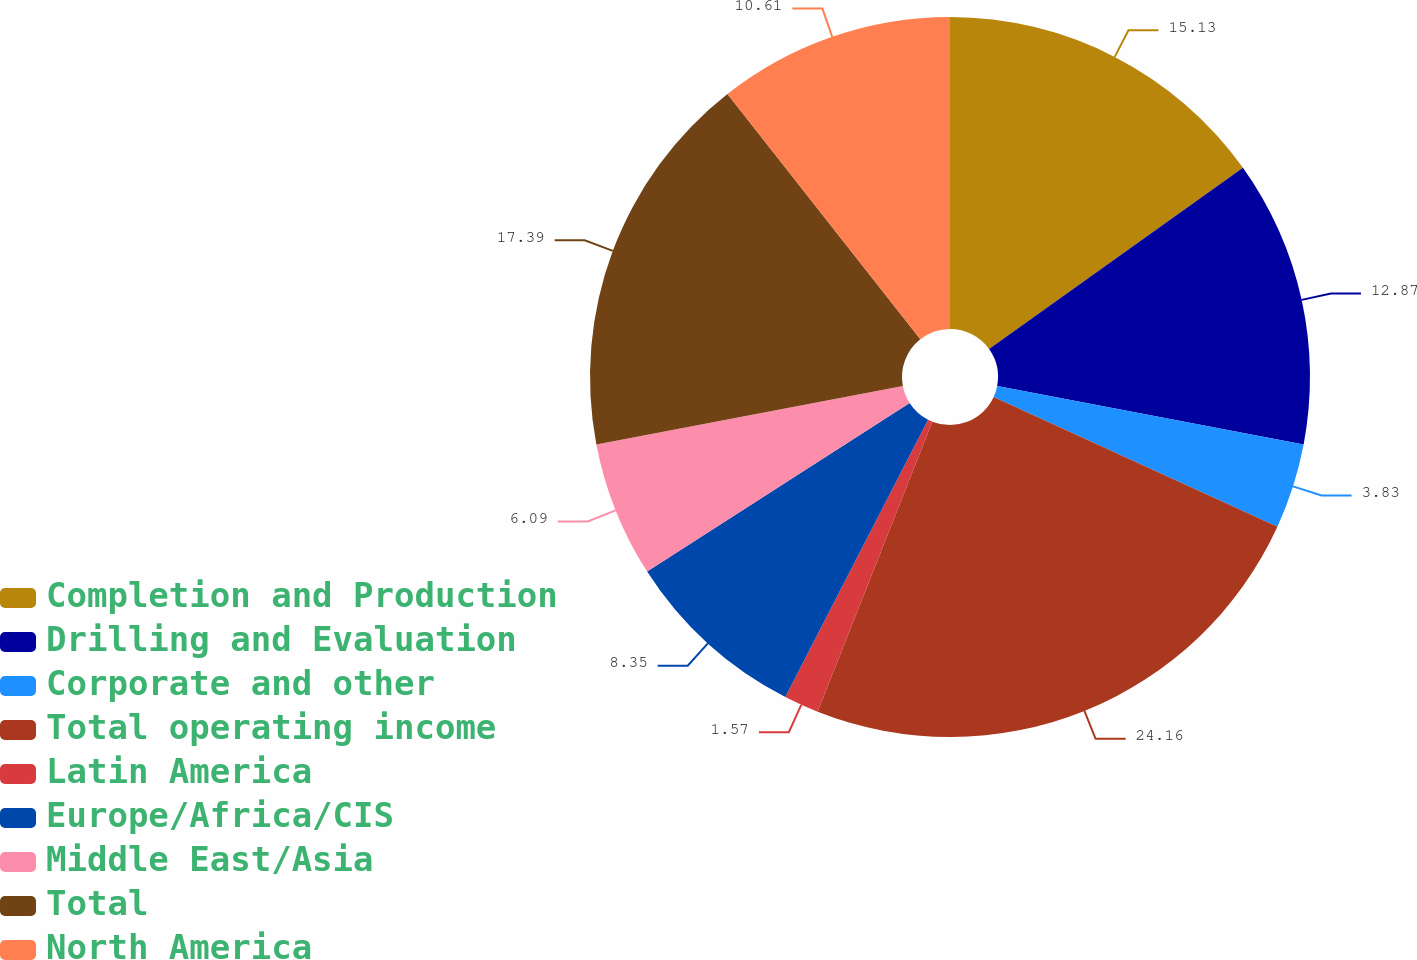<chart> <loc_0><loc_0><loc_500><loc_500><pie_chart><fcel>Completion and Production<fcel>Drilling and Evaluation<fcel>Corporate and other<fcel>Total operating income<fcel>Latin America<fcel>Europe/Africa/CIS<fcel>Middle East/Asia<fcel>Total<fcel>North America<nl><fcel>15.13%<fcel>12.87%<fcel>3.83%<fcel>24.17%<fcel>1.57%<fcel>8.35%<fcel>6.09%<fcel>17.39%<fcel>10.61%<nl></chart> 